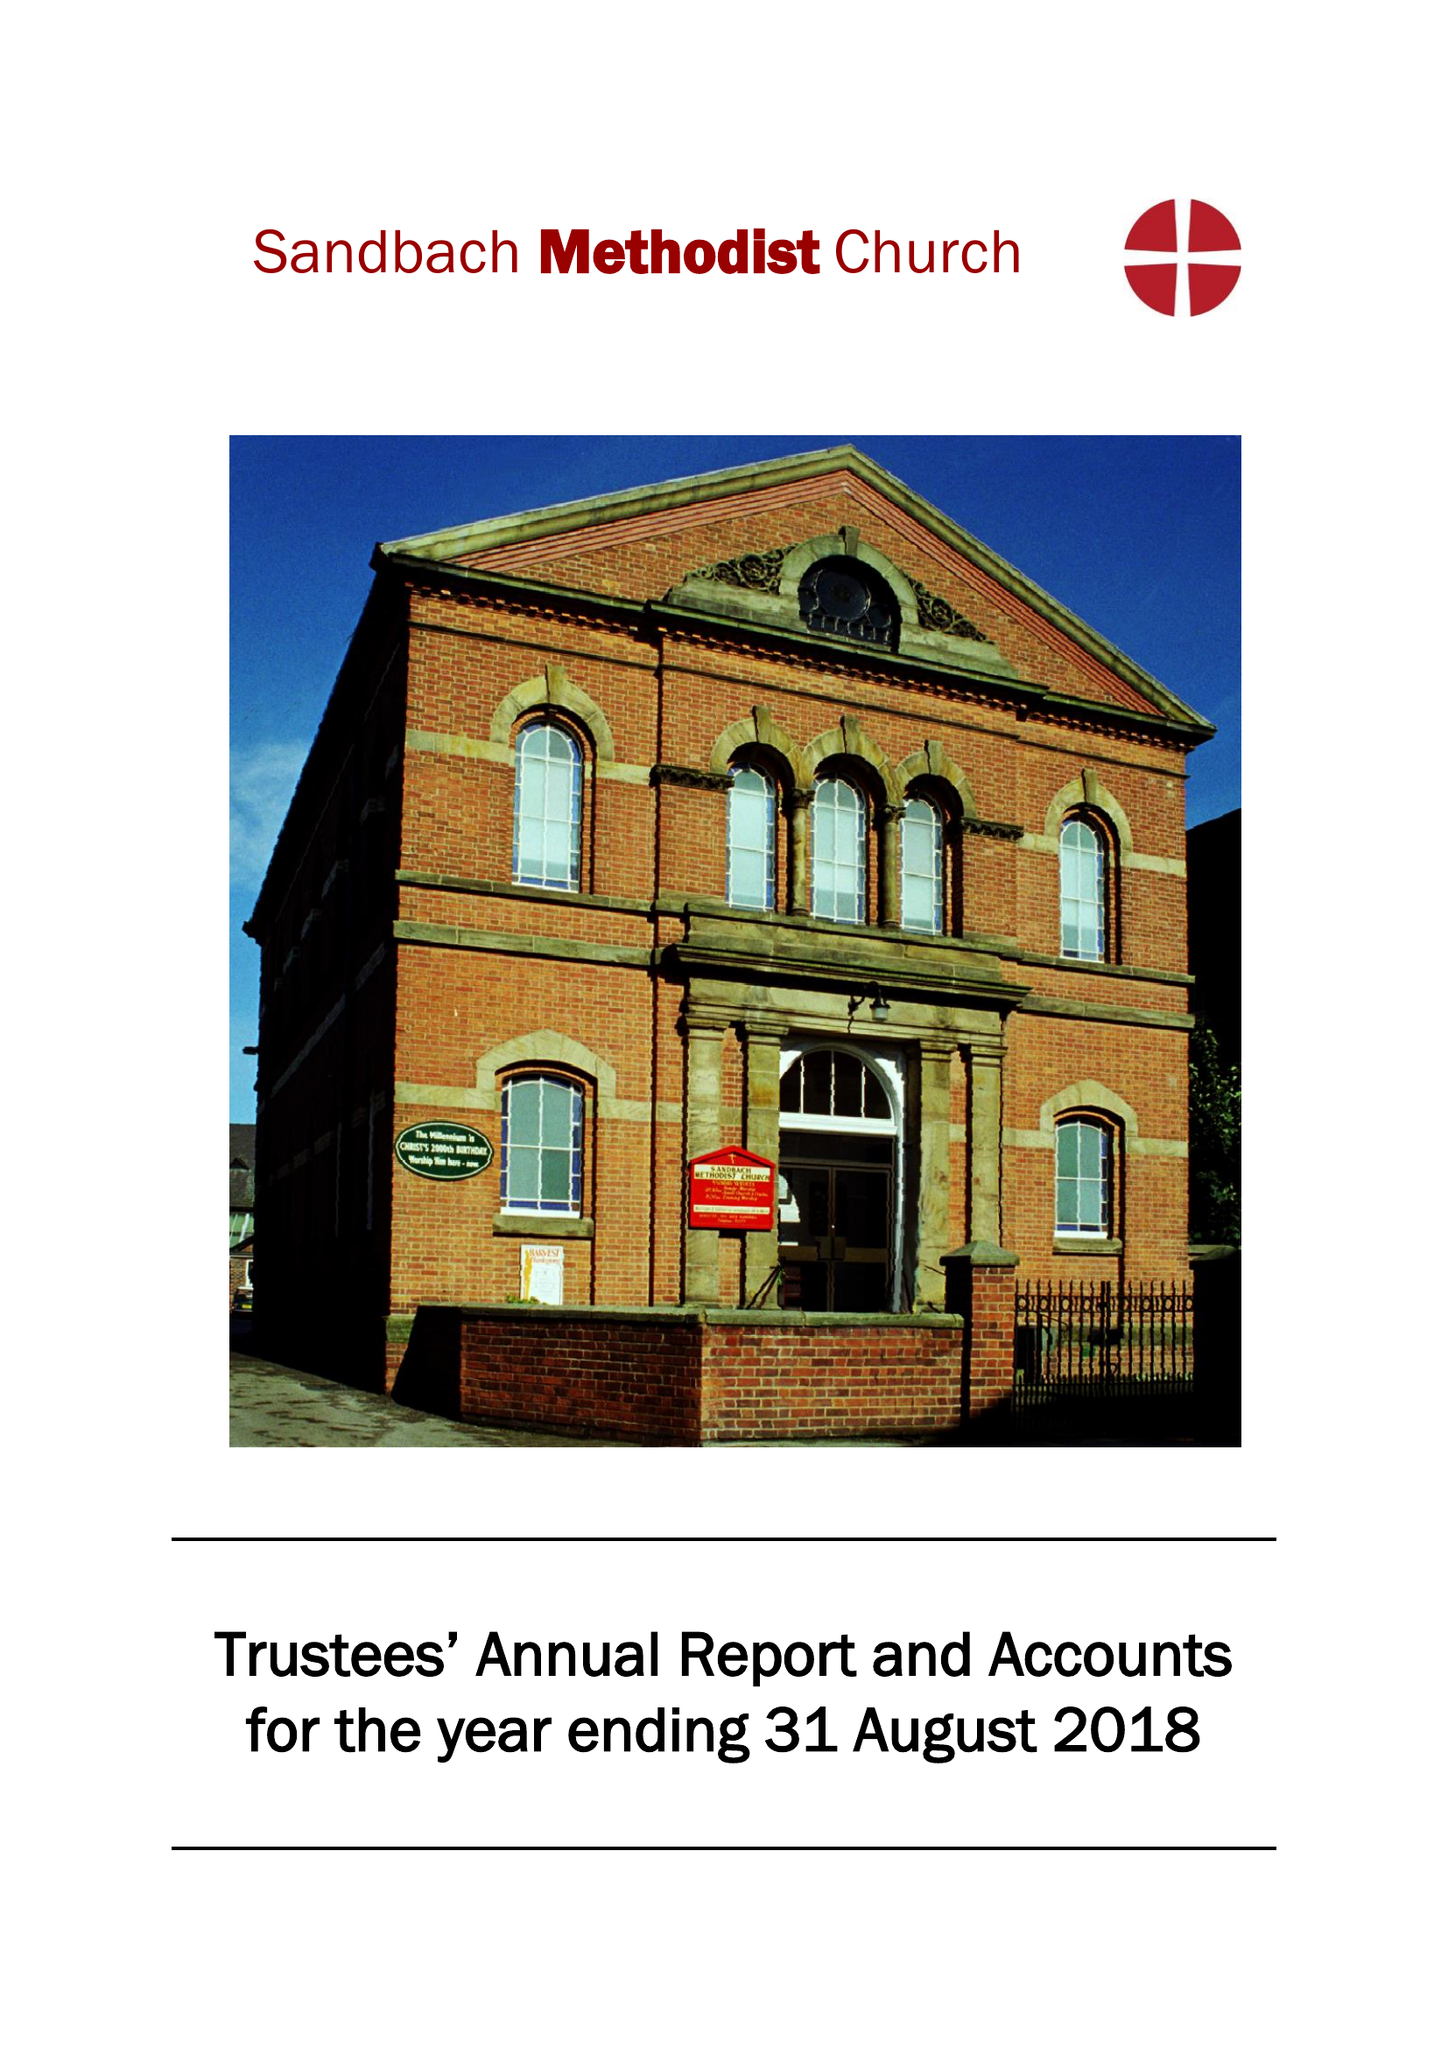What is the value for the charity_number?
Answer the question using a single word or phrase. 1173520 